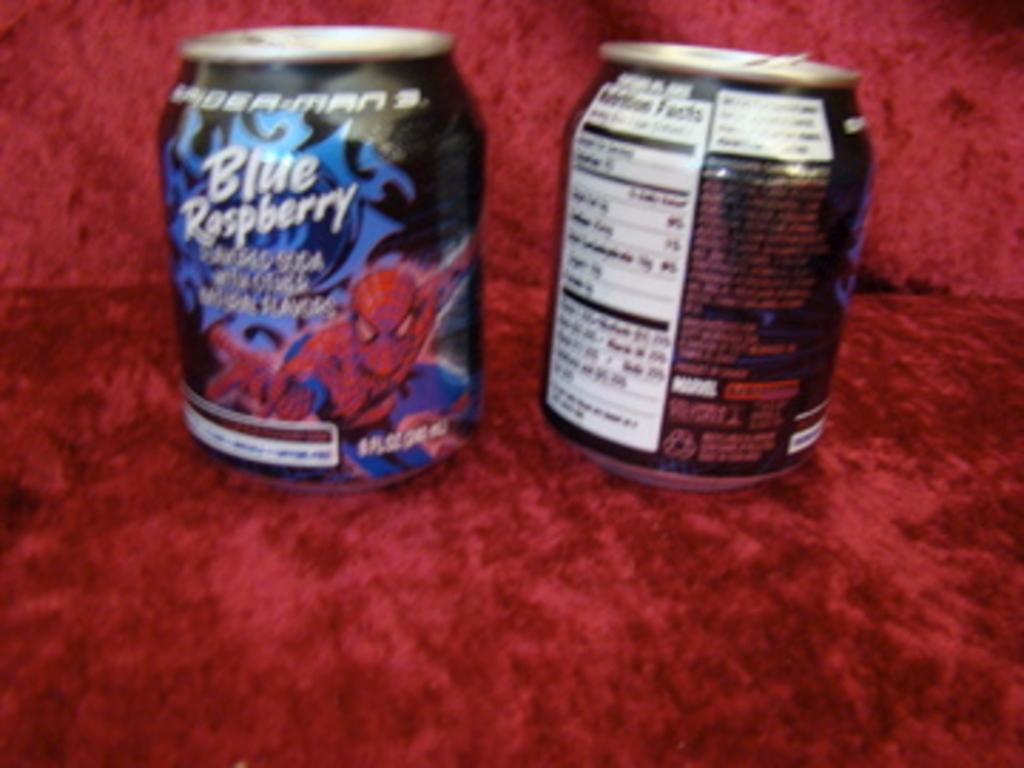<image>
Write a terse but informative summary of the picture. Small cans that say the words "Blue Raspberry" on it. 